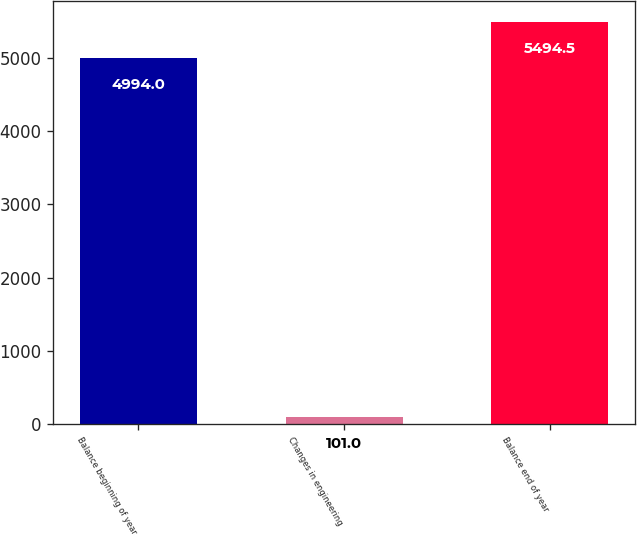<chart> <loc_0><loc_0><loc_500><loc_500><bar_chart><fcel>Balance beginning of year<fcel>Changes in engineering<fcel>Balance end of year<nl><fcel>4994<fcel>101<fcel>5494.5<nl></chart> 